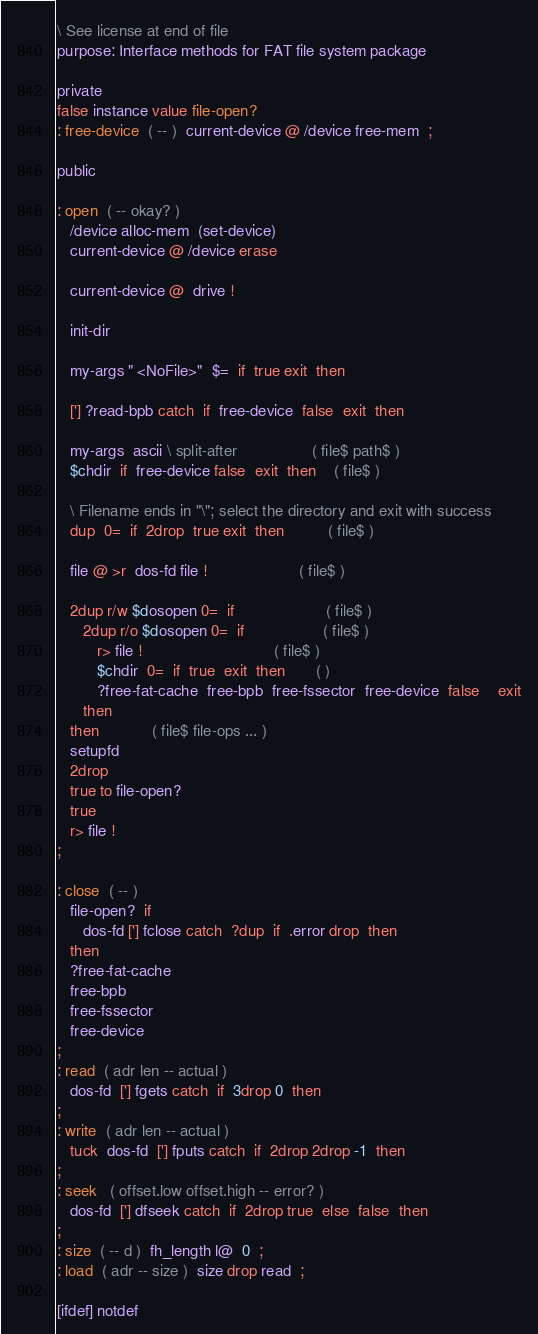Convert code to text. <code><loc_0><loc_0><loc_500><loc_500><_Forth_>\ See license at end of file
purpose: Interface methods for FAT file system package

private
false instance value file-open?
: free-device  ( -- )  current-device @ /device free-mem  ;

public

: open  ( -- okay? )
   /device alloc-mem  (set-device)
   current-device @ /device erase

   current-device @  drive !

   init-dir

   my-args " <NoFile>"  $=  if  true exit  then

   ['] ?read-bpb catch  if  free-device  false  exit  then

   my-args  ascii \ split-after                 ( file$ path$ )
   $chdir  if  free-device false  exit  then    ( file$ )

   \ Filename ends in "\"; select the directory and exit with success
   dup  0=  if  2drop  true exit  then          ( file$ )

   file @ >r  dos-fd file !                     ( file$ )

   2dup r/w $dosopen 0=  if                     ( file$ )
      2dup r/o $dosopen 0=  if                  ( file$ )
         r> file !                              ( file$ )
         $chdir  0=  if  true  exit  then       ( )
         ?free-fat-cache  free-bpb  free-fssector  free-device  false    exit
      then
   then            ( file$ file-ops ... )
   setupfd
   2drop
   true to file-open?
   true
   r> file !
;

: close  ( -- )
   file-open?  if
      dos-fd ['] fclose catch  ?dup  if  .error drop  then
   then
   ?free-fat-cache
   free-bpb
   free-fssector
   free-device
;
: read  ( adr len -- actual )
   dos-fd  ['] fgets catch  if  3drop 0  then
;
: write  ( adr len -- actual )
   tuck  dos-fd  ['] fputs catch  if  2drop 2drop -1  then
;
: seek   ( offset.low offset.high -- error? )
   dos-fd  ['] dfseek catch  if  2drop true  else  false  then
;
: size  ( -- d )  fh_length l@  0  ;
: load  ( adr -- size )  size drop read  ;

[ifdef] notdef</code> 